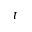Convert formula to latex. <formula><loc_0><loc_0><loc_500><loc_500>t</formula> 